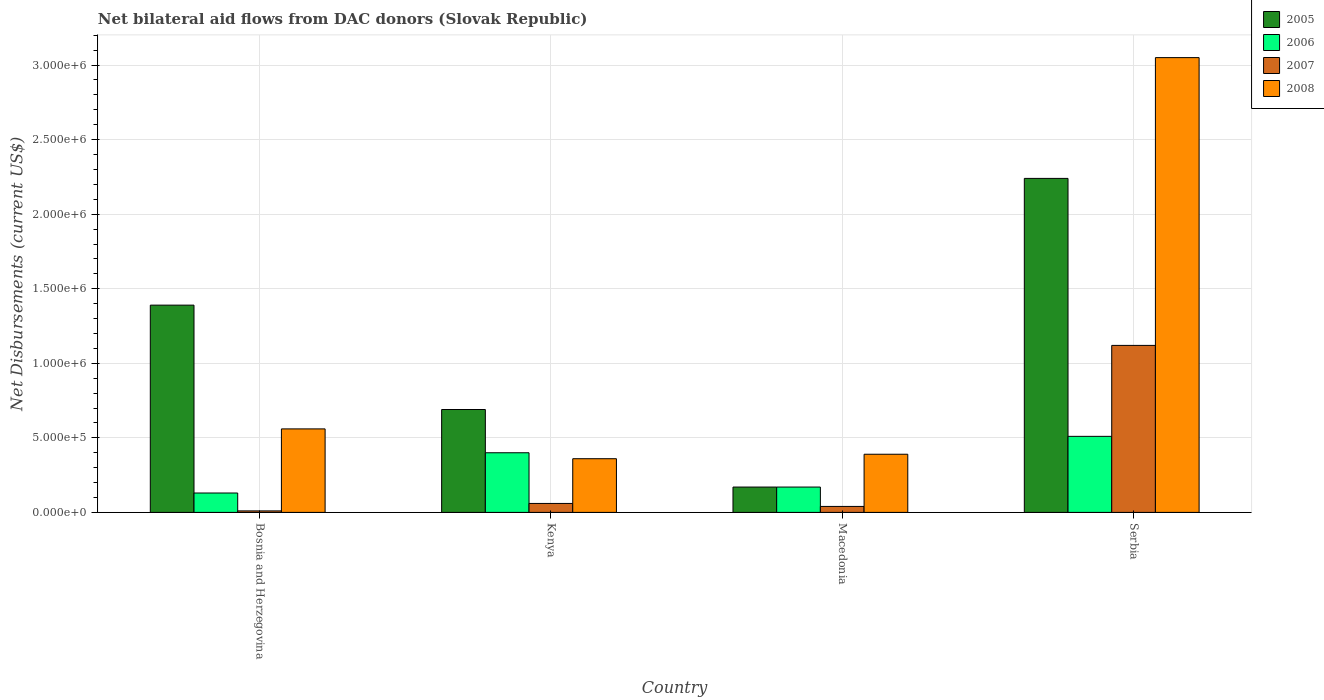How many different coloured bars are there?
Offer a terse response. 4. Are the number of bars per tick equal to the number of legend labels?
Offer a very short reply. Yes. Are the number of bars on each tick of the X-axis equal?
Provide a short and direct response. Yes. How many bars are there on the 1st tick from the left?
Your answer should be very brief. 4. How many bars are there on the 1st tick from the right?
Your response must be concise. 4. What is the label of the 2nd group of bars from the left?
Make the answer very short. Kenya. In how many cases, is the number of bars for a given country not equal to the number of legend labels?
Your answer should be compact. 0. What is the net bilateral aid flows in 2006 in Serbia?
Your answer should be very brief. 5.10e+05. Across all countries, what is the maximum net bilateral aid flows in 2006?
Keep it short and to the point. 5.10e+05. In which country was the net bilateral aid flows in 2006 maximum?
Your response must be concise. Serbia. In which country was the net bilateral aid flows in 2005 minimum?
Your answer should be very brief. Macedonia. What is the total net bilateral aid flows in 2007 in the graph?
Make the answer very short. 1.23e+06. What is the difference between the net bilateral aid flows in 2007 in Kenya and that in Serbia?
Ensure brevity in your answer.  -1.06e+06. What is the difference between the net bilateral aid flows in 2006 in Macedonia and the net bilateral aid flows in 2005 in Bosnia and Herzegovina?
Your answer should be compact. -1.22e+06. What is the average net bilateral aid flows in 2006 per country?
Provide a succinct answer. 3.02e+05. In how many countries, is the net bilateral aid flows in 2006 greater than 1800000 US$?
Offer a very short reply. 0. What is the ratio of the net bilateral aid flows in 2008 in Kenya to that in Macedonia?
Provide a succinct answer. 0.92. Is the difference between the net bilateral aid flows in 2006 in Kenya and Serbia greater than the difference between the net bilateral aid flows in 2005 in Kenya and Serbia?
Offer a very short reply. Yes. What is the difference between the highest and the second highest net bilateral aid flows in 2007?
Provide a succinct answer. 1.08e+06. What is the difference between the highest and the lowest net bilateral aid flows in 2007?
Provide a short and direct response. 1.11e+06. In how many countries, is the net bilateral aid flows in 2007 greater than the average net bilateral aid flows in 2007 taken over all countries?
Offer a terse response. 1. Is it the case that in every country, the sum of the net bilateral aid flows in 2005 and net bilateral aid flows in 2006 is greater than the sum of net bilateral aid flows in 2007 and net bilateral aid flows in 2008?
Give a very brief answer. No. What does the 3rd bar from the left in Bosnia and Herzegovina represents?
Ensure brevity in your answer.  2007. What does the 2nd bar from the right in Bosnia and Herzegovina represents?
Offer a terse response. 2007. Is it the case that in every country, the sum of the net bilateral aid flows in 2006 and net bilateral aid flows in 2008 is greater than the net bilateral aid flows in 2007?
Your answer should be compact. Yes. How many bars are there?
Keep it short and to the point. 16. How many countries are there in the graph?
Your answer should be very brief. 4. What is the difference between two consecutive major ticks on the Y-axis?
Provide a short and direct response. 5.00e+05. Are the values on the major ticks of Y-axis written in scientific E-notation?
Give a very brief answer. Yes. Does the graph contain any zero values?
Offer a very short reply. No. Does the graph contain grids?
Your answer should be compact. Yes. How are the legend labels stacked?
Give a very brief answer. Vertical. What is the title of the graph?
Offer a very short reply. Net bilateral aid flows from DAC donors (Slovak Republic). What is the label or title of the X-axis?
Keep it short and to the point. Country. What is the label or title of the Y-axis?
Your response must be concise. Net Disbursements (current US$). What is the Net Disbursements (current US$) in 2005 in Bosnia and Herzegovina?
Your answer should be compact. 1.39e+06. What is the Net Disbursements (current US$) of 2006 in Bosnia and Herzegovina?
Your answer should be very brief. 1.30e+05. What is the Net Disbursements (current US$) of 2007 in Bosnia and Herzegovina?
Make the answer very short. 10000. What is the Net Disbursements (current US$) in 2008 in Bosnia and Herzegovina?
Give a very brief answer. 5.60e+05. What is the Net Disbursements (current US$) in 2005 in Kenya?
Your response must be concise. 6.90e+05. What is the Net Disbursements (current US$) of 2006 in Kenya?
Keep it short and to the point. 4.00e+05. What is the Net Disbursements (current US$) in 2007 in Kenya?
Offer a very short reply. 6.00e+04. What is the Net Disbursements (current US$) in 2005 in Macedonia?
Provide a succinct answer. 1.70e+05. What is the Net Disbursements (current US$) of 2008 in Macedonia?
Keep it short and to the point. 3.90e+05. What is the Net Disbursements (current US$) of 2005 in Serbia?
Keep it short and to the point. 2.24e+06. What is the Net Disbursements (current US$) in 2006 in Serbia?
Give a very brief answer. 5.10e+05. What is the Net Disbursements (current US$) of 2007 in Serbia?
Give a very brief answer. 1.12e+06. What is the Net Disbursements (current US$) in 2008 in Serbia?
Offer a terse response. 3.05e+06. Across all countries, what is the maximum Net Disbursements (current US$) in 2005?
Your answer should be very brief. 2.24e+06. Across all countries, what is the maximum Net Disbursements (current US$) of 2006?
Your answer should be very brief. 5.10e+05. Across all countries, what is the maximum Net Disbursements (current US$) of 2007?
Your answer should be compact. 1.12e+06. Across all countries, what is the maximum Net Disbursements (current US$) in 2008?
Ensure brevity in your answer.  3.05e+06. Across all countries, what is the minimum Net Disbursements (current US$) in 2005?
Ensure brevity in your answer.  1.70e+05. Across all countries, what is the minimum Net Disbursements (current US$) of 2006?
Your answer should be very brief. 1.30e+05. Across all countries, what is the minimum Net Disbursements (current US$) of 2008?
Ensure brevity in your answer.  3.60e+05. What is the total Net Disbursements (current US$) in 2005 in the graph?
Give a very brief answer. 4.49e+06. What is the total Net Disbursements (current US$) of 2006 in the graph?
Keep it short and to the point. 1.21e+06. What is the total Net Disbursements (current US$) in 2007 in the graph?
Your answer should be very brief. 1.23e+06. What is the total Net Disbursements (current US$) of 2008 in the graph?
Ensure brevity in your answer.  4.36e+06. What is the difference between the Net Disbursements (current US$) of 2005 in Bosnia and Herzegovina and that in Kenya?
Offer a very short reply. 7.00e+05. What is the difference between the Net Disbursements (current US$) in 2007 in Bosnia and Herzegovina and that in Kenya?
Ensure brevity in your answer.  -5.00e+04. What is the difference between the Net Disbursements (current US$) of 2008 in Bosnia and Herzegovina and that in Kenya?
Your response must be concise. 2.00e+05. What is the difference between the Net Disbursements (current US$) in 2005 in Bosnia and Herzegovina and that in Macedonia?
Provide a short and direct response. 1.22e+06. What is the difference between the Net Disbursements (current US$) of 2007 in Bosnia and Herzegovina and that in Macedonia?
Provide a succinct answer. -3.00e+04. What is the difference between the Net Disbursements (current US$) in 2005 in Bosnia and Herzegovina and that in Serbia?
Your answer should be very brief. -8.50e+05. What is the difference between the Net Disbursements (current US$) of 2006 in Bosnia and Herzegovina and that in Serbia?
Give a very brief answer. -3.80e+05. What is the difference between the Net Disbursements (current US$) of 2007 in Bosnia and Herzegovina and that in Serbia?
Offer a terse response. -1.11e+06. What is the difference between the Net Disbursements (current US$) in 2008 in Bosnia and Herzegovina and that in Serbia?
Give a very brief answer. -2.49e+06. What is the difference between the Net Disbursements (current US$) of 2005 in Kenya and that in Macedonia?
Provide a short and direct response. 5.20e+05. What is the difference between the Net Disbursements (current US$) in 2007 in Kenya and that in Macedonia?
Make the answer very short. 2.00e+04. What is the difference between the Net Disbursements (current US$) of 2008 in Kenya and that in Macedonia?
Your answer should be compact. -3.00e+04. What is the difference between the Net Disbursements (current US$) of 2005 in Kenya and that in Serbia?
Offer a very short reply. -1.55e+06. What is the difference between the Net Disbursements (current US$) of 2007 in Kenya and that in Serbia?
Provide a succinct answer. -1.06e+06. What is the difference between the Net Disbursements (current US$) in 2008 in Kenya and that in Serbia?
Provide a short and direct response. -2.69e+06. What is the difference between the Net Disbursements (current US$) in 2005 in Macedonia and that in Serbia?
Offer a terse response. -2.07e+06. What is the difference between the Net Disbursements (current US$) of 2007 in Macedonia and that in Serbia?
Give a very brief answer. -1.08e+06. What is the difference between the Net Disbursements (current US$) in 2008 in Macedonia and that in Serbia?
Offer a very short reply. -2.66e+06. What is the difference between the Net Disbursements (current US$) in 2005 in Bosnia and Herzegovina and the Net Disbursements (current US$) in 2006 in Kenya?
Make the answer very short. 9.90e+05. What is the difference between the Net Disbursements (current US$) of 2005 in Bosnia and Herzegovina and the Net Disbursements (current US$) of 2007 in Kenya?
Keep it short and to the point. 1.33e+06. What is the difference between the Net Disbursements (current US$) of 2005 in Bosnia and Herzegovina and the Net Disbursements (current US$) of 2008 in Kenya?
Provide a short and direct response. 1.03e+06. What is the difference between the Net Disbursements (current US$) of 2007 in Bosnia and Herzegovina and the Net Disbursements (current US$) of 2008 in Kenya?
Your response must be concise. -3.50e+05. What is the difference between the Net Disbursements (current US$) of 2005 in Bosnia and Herzegovina and the Net Disbursements (current US$) of 2006 in Macedonia?
Offer a terse response. 1.22e+06. What is the difference between the Net Disbursements (current US$) of 2005 in Bosnia and Herzegovina and the Net Disbursements (current US$) of 2007 in Macedonia?
Give a very brief answer. 1.35e+06. What is the difference between the Net Disbursements (current US$) of 2005 in Bosnia and Herzegovina and the Net Disbursements (current US$) of 2008 in Macedonia?
Your response must be concise. 1.00e+06. What is the difference between the Net Disbursements (current US$) in 2006 in Bosnia and Herzegovina and the Net Disbursements (current US$) in 2007 in Macedonia?
Offer a terse response. 9.00e+04. What is the difference between the Net Disbursements (current US$) in 2006 in Bosnia and Herzegovina and the Net Disbursements (current US$) in 2008 in Macedonia?
Ensure brevity in your answer.  -2.60e+05. What is the difference between the Net Disbursements (current US$) in 2007 in Bosnia and Herzegovina and the Net Disbursements (current US$) in 2008 in Macedonia?
Make the answer very short. -3.80e+05. What is the difference between the Net Disbursements (current US$) of 2005 in Bosnia and Herzegovina and the Net Disbursements (current US$) of 2006 in Serbia?
Provide a succinct answer. 8.80e+05. What is the difference between the Net Disbursements (current US$) in 2005 in Bosnia and Herzegovina and the Net Disbursements (current US$) in 2008 in Serbia?
Provide a short and direct response. -1.66e+06. What is the difference between the Net Disbursements (current US$) of 2006 in Bosnia and Herzegovina and the Net Disbursements (current US$) of 2007 in Serbia?
Ensure brevity in your answer.  -9.90e+05. What is the difference between the Net Disbursements (current US$) in 2006 in Bosnia and Herzegovina and the Net Disbursements (current US$) in 2008 in Serbia?
Your answer should be very brief. -2.92e+06. What is the difference between the Net Disbursements (current US$) in 2007 in Bosnia and Herzegovina and the Net Disbursements (current US$) in 2008 in Serbia?
Make the answer very short. -3.04e+06. What is the difference between the Net Disbursements (current US$) of 2005 in Kenya and the Net Disbursements (current US$) of 2006 in Macedonia?
Give a very brief answer. 5.20e+05. What is the difference between the Net Disbursements (current US$) of 2005 in Kenya and the Net Disbursements (current US$) of 2007 in Macedonia?
Your answer should be compact. 6.50e+05. What is the difference between the Net Disbursements (current US$) in 2005 in Kenya and the Net Disbursements (current US$) in 2008 in Macedonia?
Give a very brief answer. 3.00e+05. What is the difference between the Net Disbursements (current US$) of 2007 in Kenya and the Net Disbursements (current US$) of 2008 in Macedonia?
Provide a short and direct response. -3.30e+05. What is the difference between the Net Disbursements (current US$) of 2005 in Kenya and the Net Disbursements (current US$) of 2007 in Serbia?
Provide a short and direct response. -4.30e+05. What is the difference between the Net Disbursements (current US$) in 2005 in Kenya and the Net Disbursements (current US$) in 2008 in Serbia?
Offer a terse response. -2.36e+06. What is the difference between the Net Disbursements (current US$) in 2006 in Kenya and the Net Disbursements (current US$) in 2007 in Serbia?
Offer a very short reply. -7.20e+05. What is the difference between the Net Disbursements (current US$) of 2006 in Kenya and the Net Disbursements (current US$) of 2008 in Serbia?
Offer a very short reply. -2.65e+06. What is the difference between the Net Disbursements (current US$) of 2007 in Kenya and the Net Disbursements (current US$) of 2008 in Serbia?
Provide a succinct answer. -2.99e+06. What is the difference between the Net Disbursements (current US$) of 2005 in Macedonia and the Net Disbursements (current US$) of 2007 in Serbia?
Keep it short and to the point. -9.50e+05. What is the difference between the Net Disbursements (current US$) of 2005 in Macedonia and the Net Disbursements (current US$) of 2008 in Serbia?
Your answer should be very brief. -2.88e+06. What is the difference between the Net Disbursements (current US$) of 2006 in Macedonia and the Net Disbursements (current US$) of 2007 in Serbia?
Provide a succinct answer. -9.50e+05. What is the difference between the Net Disbursements (current US$) in 2006 in Macedonia and the Net Disbursements (current US$) in 2008 in Serbia?
Your answer should be compact. -2.88e+06. What is the difference between the Net Disbursements (current US$) of 2007 in Macedonia and the Net Disbursements (current US$) of 2008 in Serbia?
Provide a short and direct response. -3.01e+06. What is the average Net Disbursements (current US$) in 2005 per country?
Ensure brevity in your answer.  1.12e+06. What is the average Net Disbursements (current US$) of 2006 per country?
Provide a succinct answer. 3.02e+05. What is the average Net Disbursements (current US$) of 2007 per country?
Your answer should be compact. 3.08e+05. What is the average Net Disbursements (current US$) of 2008 per country?
Offer a terse response. 1.09e+06. What is the difference between the Net Disbursements (current US$) in 2005 and Net Disbursements (current US$) in 2006 in Bosnia and Herzegovina?
Offer a terse response. 1.26e+06. What is the difference between the Net Disbursements (current US$) in 2005 and Net Disbursements (current US$) in 2007 in Bosnia and Herzegovina?
Give a very brief answer. 1.38e+06. What is the difference between the Net Disbursements (current US$) in 2005 and Net Disbursements (current US$) in 2008 in Bosnia and Herzegovina?
Provide a short and direct response. 8.30e+05. What is the difference between the Net Disbursements (current US$) in 2006 and Net Disbursements (current US$) in 2008 in Bosnia and Herzegovina?
Ensure brevity in your answer.  -4.30e+05. What is the difference between the Net Disbursements (current US$) in 2007 and Net Disbursements (current US$) in 2008 in Bosnia and Herzegovina?
Offer a terse response. -5.50e+05. What is the difference between the Net Disbursements (current US$) in 2005 and Net Disbursements (current US$) in 2007 in Kenya?
Offer a terse response. 6.30e+05. What is the difference between the Net Disbursements (current US$) in 2006 and Net Disbursements (current US$) in 2007 in Kenya?
Offer a very short reply. 3.40e+05. What is the difference between the Net Disbursements (current US$) of 2006 and Net Disbursements (current US$) of 2008 in Kenya?
Give a very brief answer. 4.00e+04. What is the difference between the Net Disbursements (current US$) of 2007 and Net Disbursements (current US$) of 2008 in Kenya?
Make the answer very short. -3.00e+05. What is the difference between the Net Disbursements (current US$) of 2005 and Net Disbursements (current US$) of 2006 in Macedonia?
Offer a terse response. 0. What is the difference between the Net Disbursements (current US$) in 2005 and Net Disbursements (current US$) in 2007 in Macedonia?
Your answer should be compact. 1.30e+05. What is the difference between the Net Disbursements (current US$) in 2006 and Net Disbursements (current US$) in 2007 in Macedonia?
Make the answer very short. 1.30e+05. What is the difference between the Net Disbursements (current US$) of 2007 and Net Disbursements (current US$) of 2008 in Macedonia?
Give a very brief answer. -3.50e+05. What is the difference between the Net Disbursements (current US$) of 2005 and Net Disbursements (current US$) of 2006 in Serbia?
Your response must be concise. 1.73e+06. What is the difference between the Net Disbursements (current US$) in 2005 and Net Disbursements (current US$) in 2007 in Serbia?
Give a very brief answer. 1.12e+06. What is the difference between the Net Disbursements (current US$) of 2005 and Net Disbursements (current US$) of 2008 in Serbia?
Offer a very short reply. -8.10e+05. What is the difference between the Net Disbursements (current US$) in 2006 and Net Disbursements (current US$) in 2007 in Serbia?
Provide a succinct answer. -6.10e+05. What is the difference between the Net Disbursements (current US$) of 2006 and Net Disbursements (current US$) of 2008 in Serbia?
Give a very brief answer. -2.54e+06. What is the difference between the Net Disbursements (current US$) of 2007 and Net Disbursements (current US$) of 2008 in Serbia?
Your answer should be compact. -1.93e+06. What is the ratio of the Net Disbursements (current US$) in 2005 in Bosnia and Herzegovina to that in Kenya?
Your response must be concise. 2.01. What is the ratio of the Net Disbursements (current US$) of 2006 in Bosnia and Herzegovina to that in Kenya?
Offer a very short reply. 0.33. What is the ratio of the Net Disbursements (current US$) of 2008 in Bosnia and Herzegovina to that in Kenya?
Keep it short and to the point. 1.56. What is the ratio of the Net Disbursements (current US$) of 2005 in Bosnia and Herzegovina to that in Macedonia?
Give a very brief answer. 8.18. What is the ratio of the Net Disbursements (current US$) of 2006 in Bosnia and Herzegovina to that in Macedonia?
Your answer should be compact. 0.76. What is the ratio of the Net Disbursements (current US$) of 2007 in Bosnia and Herzegovina to that in Macedonia?
Provide a short and direct response. 0.25. What is the ratio of the Net Disbursements (current US$) in 2008 in Bosnia and Herzegovina to that in Macedonia?
Your answer should be compact. 1.44. What is the ratio of the Net Disbursements (current US$) of 2005 in Bosnia and Herzegovina to that in Serbia?
Offer a terse response. 0.62. What is the ratio of the Net Disbursements (current US$) in 2006 in Bosnia and Herzegovina to that in Serbia?
Provide a succinct answer. 0.25. What is the ratio of the Net Disbursements (current US$) in 2007 in Bosnia and Herzegovina to that in Serbia?
Make the answer very short. 0.01. What is the ratio of the Net Disbursements (current US$) in 2008 in Bosnia and Herzegovina to that in Serbia?
Keep it short and to the point. 0.18. What is the ratio of the Net Disbursements (current US$) of 2005 in Kenya to that in Macedonia?
Keep it short and to the point. 4.06. What is the ratio of the Net Disbursements (current US$) of 2006 in Kenya to that in Macedonia?
Offer a terse response. 2.35. What is the ratio of the Net Disbursements (current US$) of 2008 in Kenya to that in Macedonia?
Give a very brief answer. 0.92. What is the ratio of the Net Disbursements (current US$) of 2005 in Kenya to that in Serbia?
Provide a succinct answer. 0.31. What is the ratio of the Net Disbursements (current US$) of 2006 in Kenya to that in Serbia?
Provide a succinct answer. 0.78. What is the ratio of the Net Disbursements (current US$) of 2007 in Kenya to that in Serbia?
Keep it short and to the point. 0.05. What is the ratio of the Net Disbursements (current US$) of 2008 in Kenya to that in Serbia?
Your answer should be very brief. 0.12. What is the ratio of the Net Disbursements (current US$) in 2005 in Macedonia to that in Serbia?
Provide a short and direct response. 0.08. What is the ratio of the Net Disbursements (current US$) in 2006 in Macedonia to that in Serbia?
Offer a terse response. 0.33. What is the ratio of the Net Disbursements (current US$) in 2007 in Macedonia to that in Serbia?
Your answer should be compact. 0.04. What is the ratio of the Net Disbursements (current US$) of 2008 in Macedonia to that in Serbia?
Give a very brief answer. 0.13. What is the difference between the highest and the second highest Net Disbursements (current US$) of 2005?
Ensure brevity in your answer.  8.50e+05. What is the difference between the highest and the second highest Net Disbursements (current US$) in 2007?
Provide a short and direct response. 1.06e+06. What is the difference between the highest and the second highest Net Disbursements (current US$) of 2008?
Make the answer very short. 2.49e+06. What is the difference between the highest and the lowest Net Disbursements (current US$) of 2005?
Your response must be concise. 2.07e+06. What is the difference between the highest and the lowest Net Disbursements (current US$) of 2006?
Your answer should be very brief. 3.80e+05. What is the difference between the highest and the lowest Net Disbursements (current US$) in 2007?
Give a very brief answer. 1.11e+06. What is the difference between the highest and the lowest Net Disbursements (current US$) of 2008?
Keep it short and to the point. 2.69e+06. 